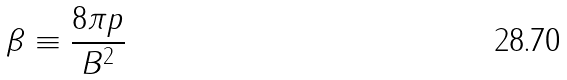Convert formula to latex. <formula><loc_0><loc_0><loc_500><loc_500>\beta \equiv \frac { 8 \pi p } { B ^ { 2 } }</formula> 